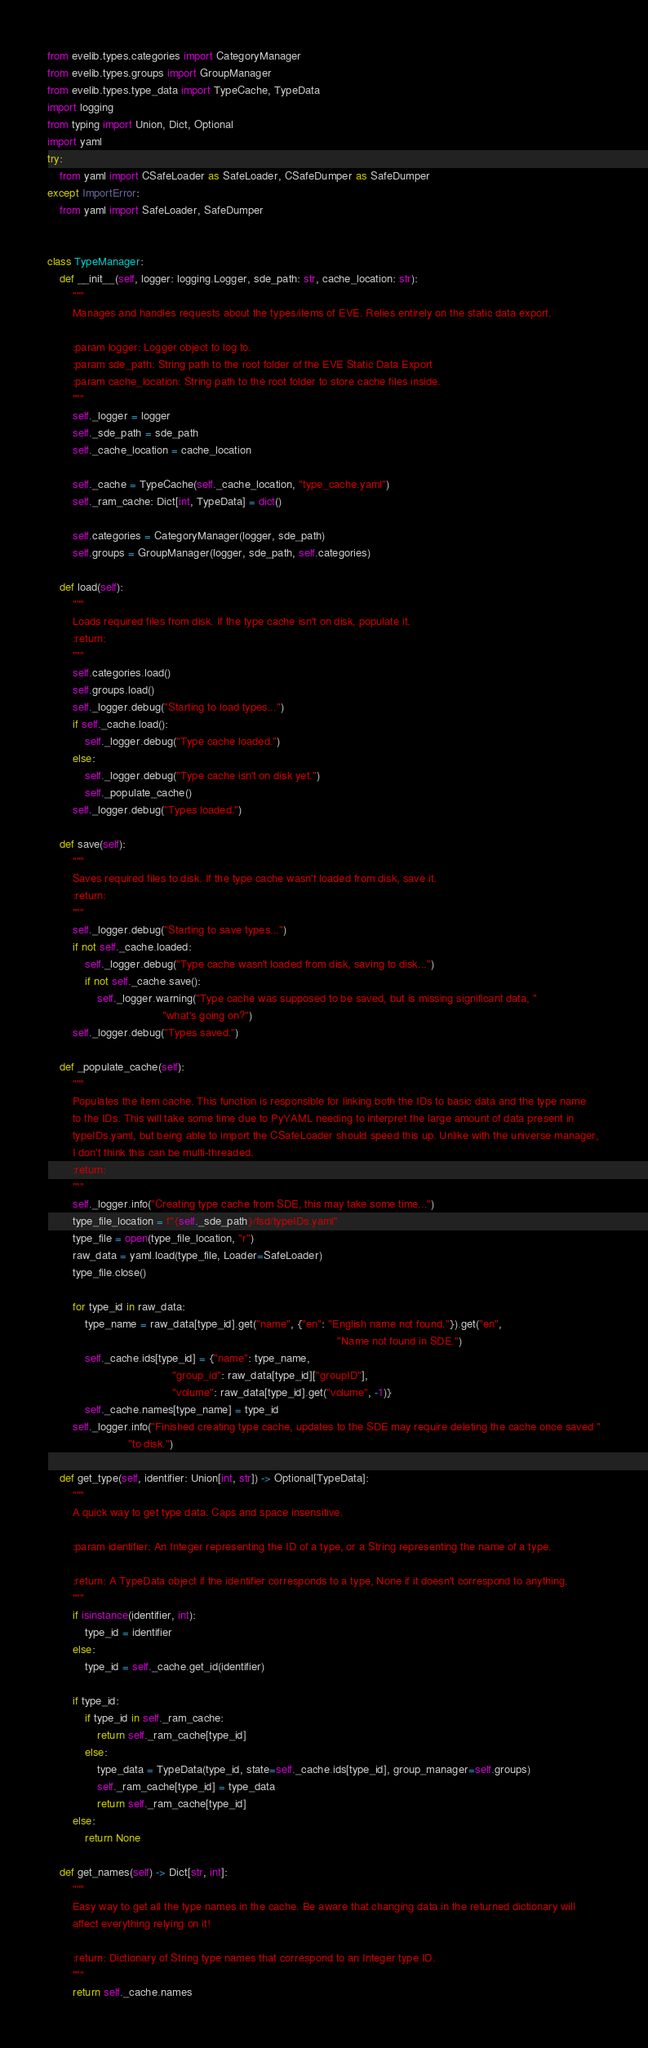Convert code to text. <code><loc_0><loc_0><loc_500><loc_500><_Python_>from evelib.types.categories import CategoryManager
from evelib.types.groups import GroupManager
from evelib.types.type_data import TypeCache, TypeData
import logging
from typing import Union, Dict, Optional
import yaml
try:
    from yaml import CSafeLoader as SafeLoader, CSafeDumper as SafeDumper
except ImportError:
    from yaml import SafeLoader, SafeDumper


class TypeManager:
    def __init__(self, logger: logging.Logger, sde_path: str, cache_location: str):
        """
        Manages and handles requests about the types/items of EVE. Relies entirely on the static data export.

        :param logger: Logger object to log to.
        :param sde_path: String path to the root folder of the EVE Static Data Export
        :param cache_location: String path to the root folder to store cache files inside.
        """
        self._logger = logger
        self._sde_path = sde_path
        self._cache_location = cache_location

        self._cache = TypeCache(self._cache_location, "type_cache.yaml")
        self._ram_cache: Dict[int, TypeData] = dict()

        self.categories = CategoryManager(logger, sde_path)
        self.groups = GroupManager(logger, sde_path, self.categories)

    def load(self):
        """
        Loads required files from disk. If the type cache isn't on disk, populate it.
        :return:
        """
        self.categories.load()
        self.groups.load()
        self._logger.debug("Starting to load types...")
        if self._cache.load():
            self._logger.debug("Type cache loaded.")
        else:
            self._logger.debug("Type cache isn't on disk yet.")
            self._populate_cache()
        self._logger.debug("Types loaded.")

    def save(self):
        """
        Saves required files to disk. If the type cache wasn't loaded from disk, save it.
        :return:
        """
        self._logger.debug("Starting to save types...")
        if not self._cache.loaded:
            self._logger.debug("Type cache wasn't loaded from disk, saving to disk...")
            if not self._cache.save():
                self._logger.warning("Type cache was supposed to be saved, but is missing significant data, "
                                     "what's going on?")
        self._logger.debug("Types saved.")

    def _populate_cache(self):
        """
        Populates the item cache. This function is responsible for linking both the IDs to basic data and the type name
        to the IDs. This will take some time due to PyYAML needing to interpret the large amount of data present in
        typeIDs.yaml, but being able to import the CSafeLoader should speed this up. Unlike with the universe manager,
        I don't think this can be multi-threaded.
        :return:
        """
        self._logger.info("Creating type cache from SDE, this may take some time...")
        type_file_location = f"{self._sde_path}/fsd/typeIDs.yaml"
        type_file = open(type_file_location, "r")
        raw_data = yaml.load(type_file, Loader=SafeLoader)
        type_file.close()

        for type_id in raw_data:
            type_name = raw_data[type_id].get("name", {"en": "English name not found."}).get("en",
                                                                                             "Name not found in SDE.")
            self._cache.ids[type_id] = {"name": type_name,
                                        "group_id": raw_data[type_id]["groupID"],
                                        "volume": raw_data[type_id].get("volume", -1)}
            self._cache.names[type_name] = type_id
        self._logger.info("Finished creating type cache, updates to the SDE may require deleting the cache once saved "
                          "to disk.")

    def get_type(self, identifier: Union[int, str]) -> Optional[TypeData]:
        """
        A quick way to get type data. Caps and space insensitive.

        :param identifier: An Integer representing the ID of a type, or a String representing the name of a type.

        :return: A TypeData object if the identifier corresponds to a type, None if it doesn't correspond to anything.
        """
        if isinstance(identifier, int):
            type_id = identifier
        else:
            type_id = self._cache.get_id(identifier)

        if type_id:
            if type_id in self._ram_cache:
                return self._ram_cache[type_id]
            else:
                type_data = TypeData(type_id, state=self._cache.ids[type_id], group_manager=self.groups)
                self._ram_cache[type_id] = type_data
                return self._ram_cache[type_id]
        else:
            return None

    def get_names(self) -> Dict[str, int]:
        """
        Easy way to get all the type names in the cache. Be aware that changing data in the returned dictionary will
        affect everything relying on it!

        :return: Dictionary of String type names that correspond to an Integer type ID.
        """
        return self._cache.names
</code> 